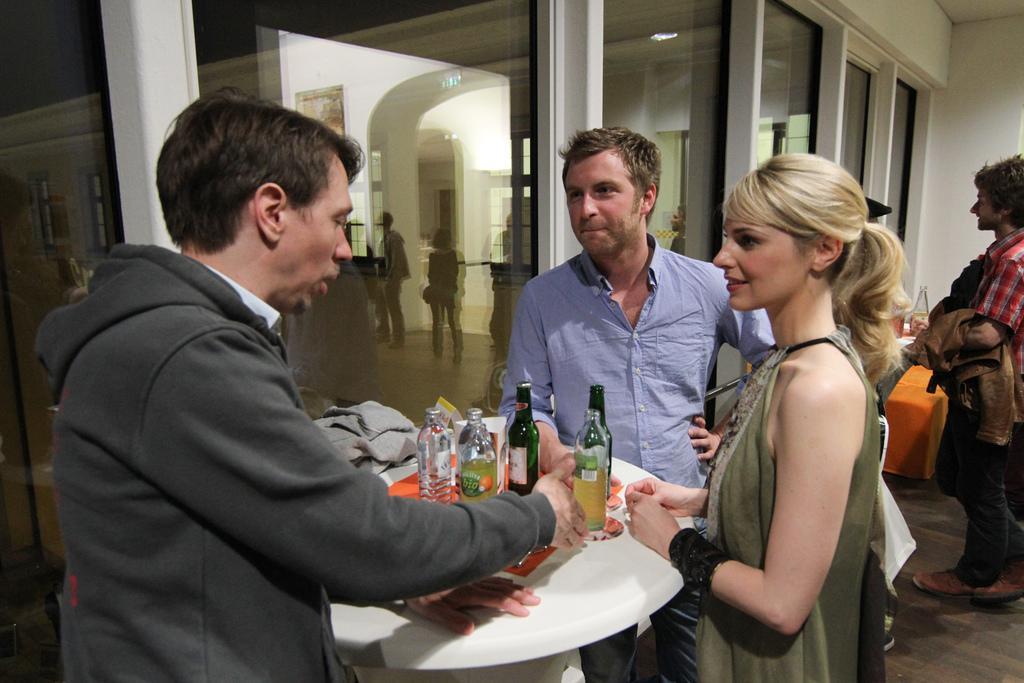Can you describe this image briefly? There are three persons standing. In front of him there is a table. On the table there are bottles and jackets. Behind him another person is standing. And there is a wall with glass in the background. 